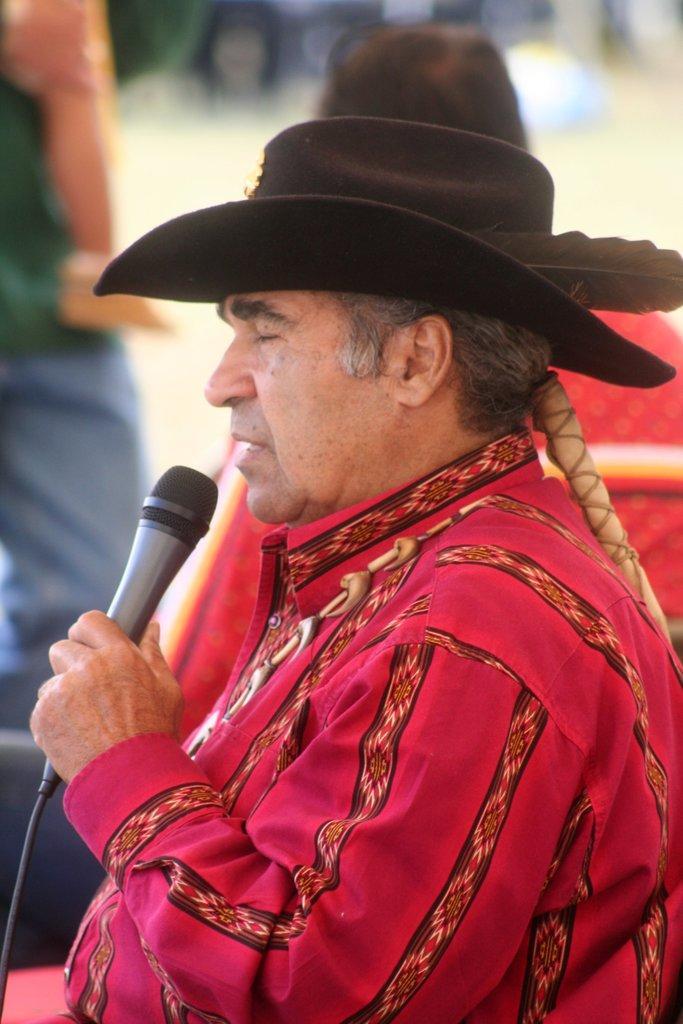How would you summarize this image in a sentence or two? In this image their is a man who is holding a mic in his hand and wearing a hat on his head. 